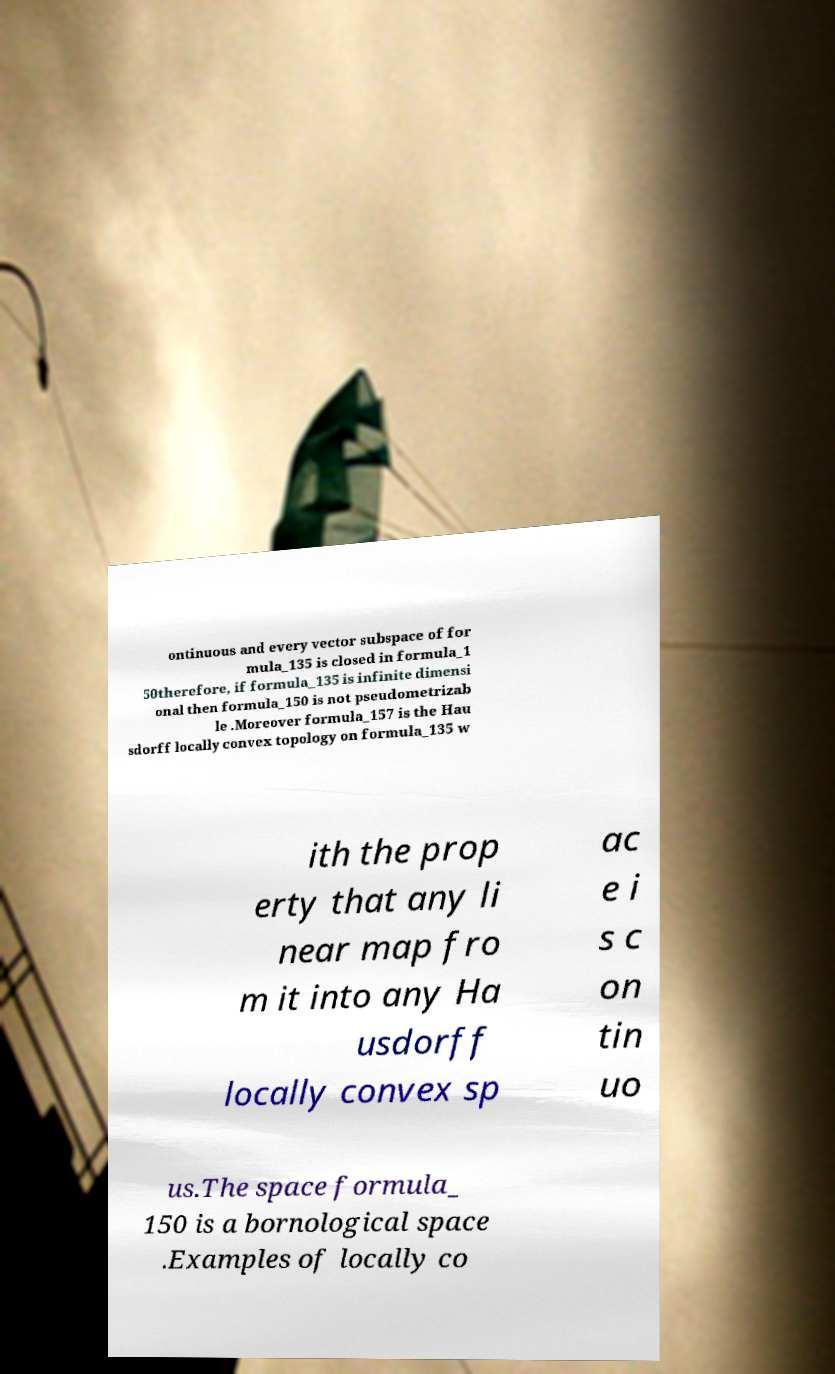Can you read and provide the text displayed in the image?This photo seems to have some interesting text. Can you extract and type it out for me? ontinuous and every vector subspace of for mula_135 is closed in formula_1 50therefore, if formula_135 is infinite dimensi onal then formula_150 is not pseudometrizab le .Moreover formula_157 is the Hau sdorff locally convex topology on formula_135 w ith the prop erty that any li near map fro m it into any Ha usdorff locally convex sp ac e i s c on tin uo us.The space formula_ 150 is a bornological space .Examples of locally co 